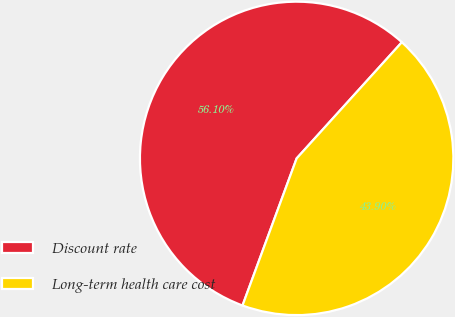Convert chart to OTSL. <chart><loc_0><loc_0><loc_500><loc_500><pie_chart><fcel>Discount rate<fcel>Long-term health care cost<nl><fcel>56.1%<fcel>43.9%<nl></chart> 